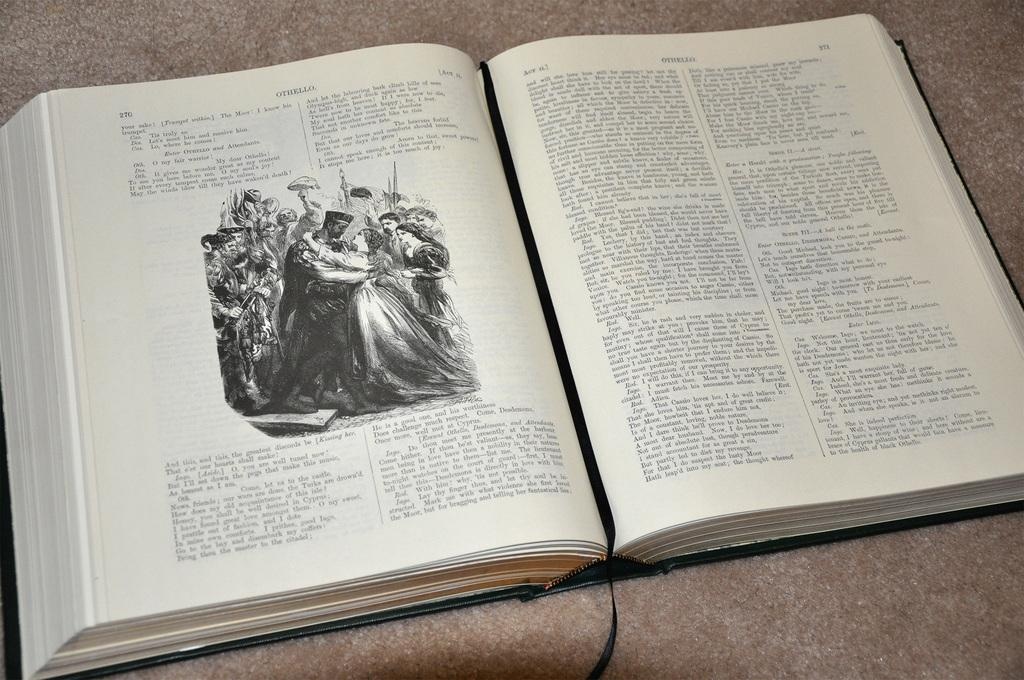What is present in the image related to reading material? There is a book in the image. Can you describe the state of the book? The book is open. What can be found on the pages of the book? There is text and a picture on the pages of the book. What type of base is used to support the book in the image? There is no base visible in the image; the book is simply open on a surface. 